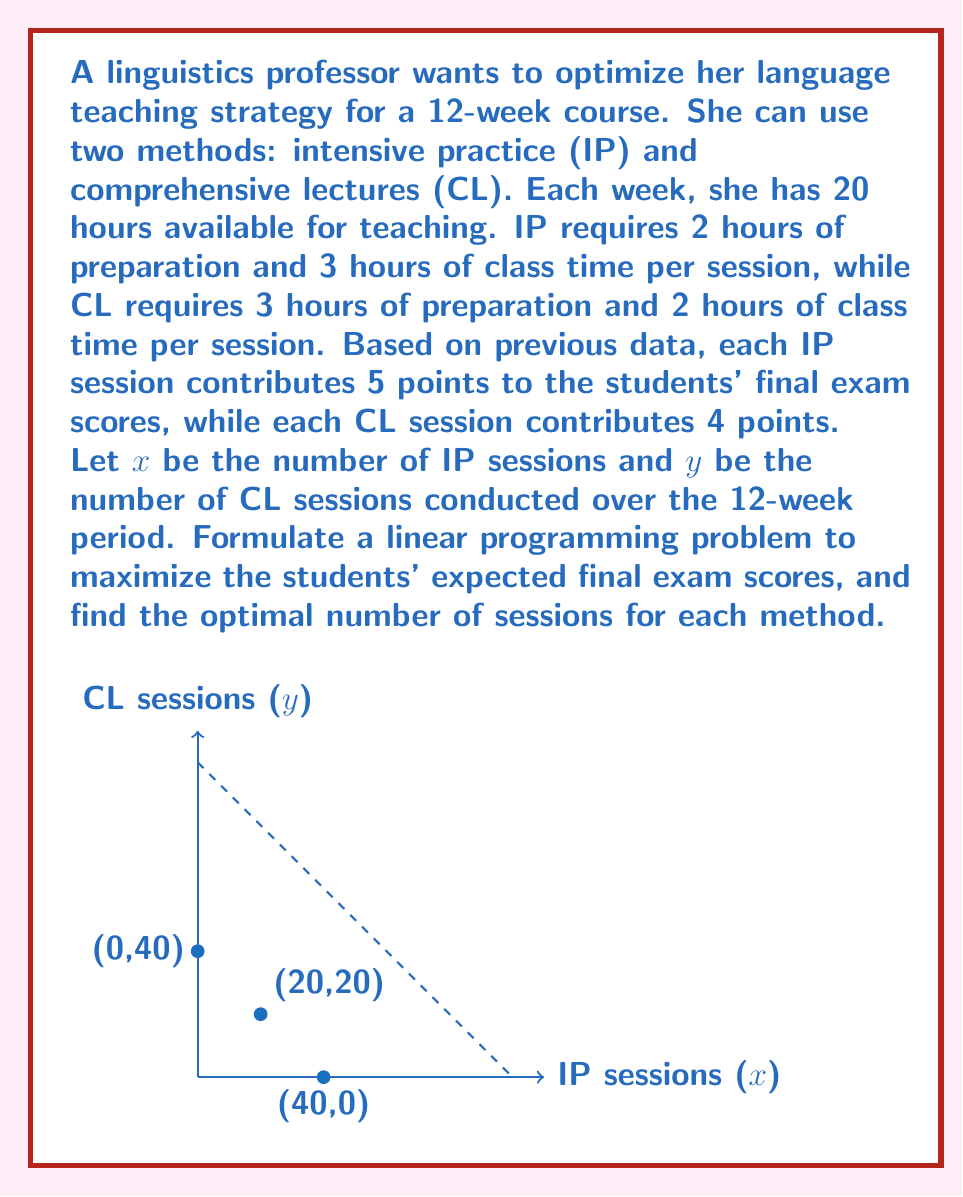Help me with this question. Let's approach this step-by-step:

1) First, we need to formulate the objective function. We want to maximize the total contribution to the final exam scores:
   Maximize: $Z = 5x + 4y$

2) Now, let's identify the constraints:

   a) Time constraint: The total time spent on both methods cannot exceed the available time.
      For IP: $(2 + 3)x = 5x$ hours per week
      For CL: $(3 + 2)y = 5y$ hours per week
      Total time constraint: $5x + 5y \leq 20 \cdot 12 = 240$ (20 hours per week for 12 weeks)

   b) Non-negativity constraints: $x \geq 0, y \geq 0$

3) Our linear programming problem is now:
   Maximize: $Z = 5x + 4y$
   Subject to:
   $5x + 5y \leq 240$
   $x \geq 0, y \geq 0$

4) To solve this, we can use the graphical method:

   a) Plot the constraint: $5x + 5y = 240$ or $y = 48 - x$
   b) The feasible region is the area below this line in the first quadrant.
   c) The optimal solution will be at one of the corner points of the feasible region.

5) The corner points are:
   (0, 0), (0, 48), and (48, 0)

6) Evaluating the objective function at these points:
   At (0, 0): $Z = 0$
   At (0, 48): $Z = 4 \cdot 48 = 192$
   At (48, 0): $Z = 5 \cdot 48 = 240$

7) The maximum value occurs at (48, 0), which means 48 IP sessions and 0 CL sessions.
Answer: 48 IP sessions, 0 CL sessions 